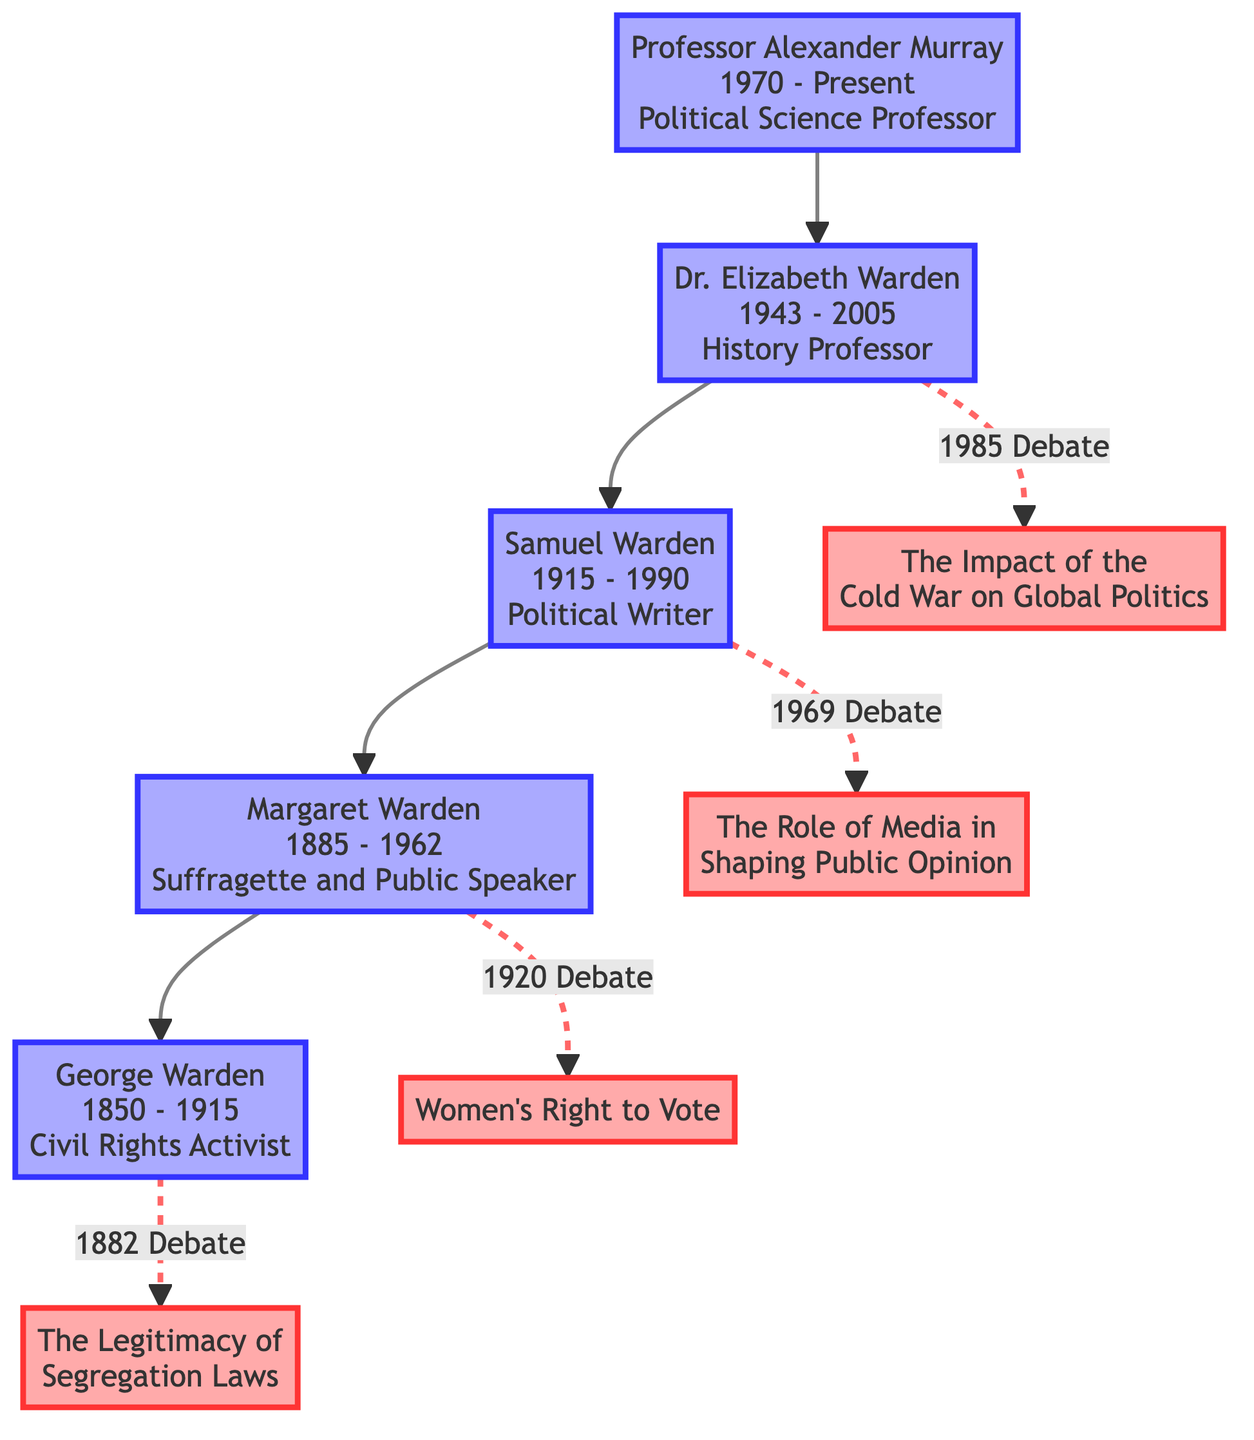What is the birth year of Professor Alexander Murray? The diagram clearly states that Professor Alexander Murray was born in 1970.
Answer: 1970 How many notable debates did Dr. Elizabeth Warden participate in? The diagram shows that Dr. Elizabeth Warden took part in one notable debate, which is represented by one connecting line in the flowchart.
Answer: 1 Who was George Warden's opponent in the 1882 debate? The diagram indicates that George Warden's opponent in the 1882 debate was Judge Thomas Palmer, linked directly to the debate topic.
Answer: Judge Thomas Palmer What topic did Samuel Warden debate in 1969? The diagram shows that Samuel Warden debated the topic "The Role of Media in Shaping Public Opinion" in 1969, as indicated by the label connected to his name.
Answer: The Role of Media in Shaping Public Opinion Which ancestor was a suffragette and public speaker? The diagram identifies Margaret Warden as the ancestor who was a suffragette and public speaker, as explicitly labeled next to her name.
Answer: Margaret Warden How many generations of prominent debaters are depicted in the diagram? The descendants of Professor Alexander Murray, shown as four generations, including himself, Dr. Elizabeth Warden, Samuel Warden, Margaret Warden, and George Warden, means there are a total of four generations represented.
Answer: 4 What year did Margaret Warden's notable debate take place? According to the diagram, Margaret Warden's notable debate occurred in the year 1920, clearly mentioned alongside her name and labeled with the debate topic.
Answer: 1920 Which topic links Dr. Elizabeth Warden to Dr. Henry Wilson? The diagram establishes that Dr. Elizabeth Warden debated "The Impact of the Cold War on Global Politics" against her opponent Dr. Henry Wilson, which can be traced from her node to the debate node.
Answer: The Impact of the Cold War on Global Politics What was the occupation of George Warden? The diagram indicates that George Warden was a Civil Rights Activist, as denoted next to his name in the flowchart.
Answer: Civil Rights Activist 